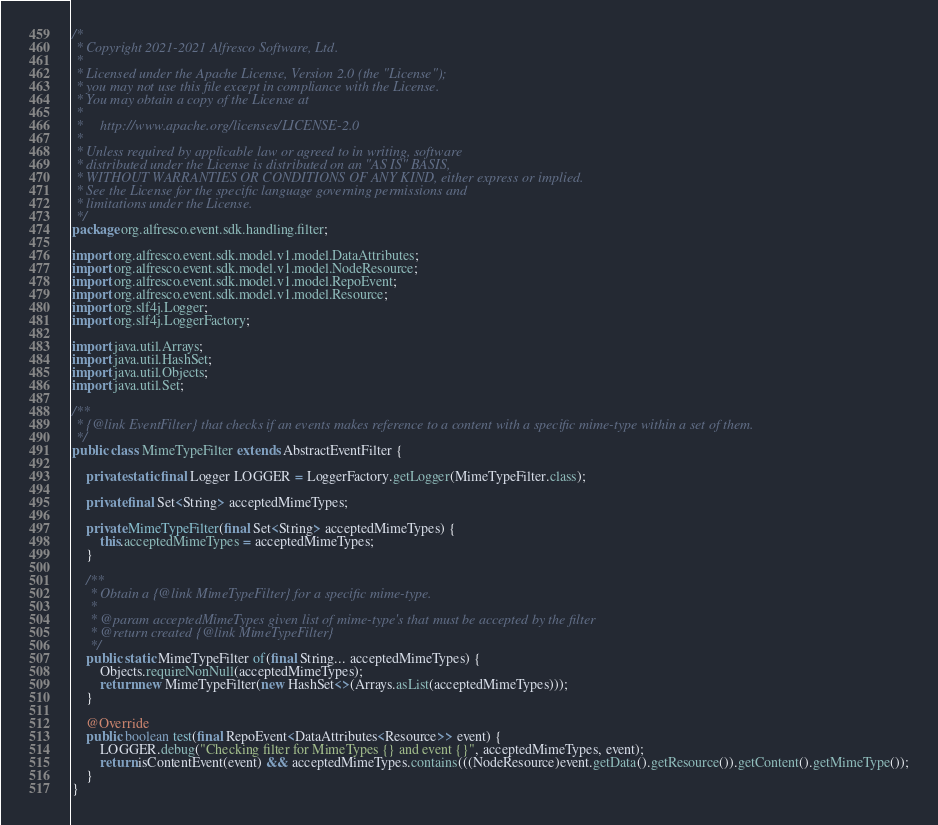<code> <loc_0><loc_0><loc_500><loc_500><_Java_>/*
 * Copyright 2021-2021 Alfresco Software, Ltd.
 *
 * Licensed under the Apache License, Version 2.0 (the "License");
 * you may not use this file except in compliance with the License.
 * You may obtain a copy of the License at
 *
 *     http://www.apache.org/licenses/LICENSE-2.0
 *
 * Unless required by applicable law or agreed to in writing, software
 * distributed under the License is distributed on an "AS IS" BASIS,
 * WITHOUT WARRANTIES OR CONDITIONS OF ANY KIND, either express or implied.
 * See the License for the specific language governing permissions and
 * limitations under the License.
 */
package org.alfresco.event.sdk.handling.filter;

import org.alfresco.event.sdk.model.v1.model.DataAttributes;
import org.alfresco.event.sdk.model.v1.model.NodeResource;
import org.alfresco.event.sdk.model.v1.model.RepoEvent;
import org.alfresco.event.sdk.model.v1.model.Resource;
import org.slf4j.Logger;
import org.slf4j.LoggerFactory;

import java.util.Arrays;
import java.util.HashSet;
import java.util.Objects;
import java.util.Set;

/**
 * {@link EventFilter} that checks if an events makes reference to a content with a specific mime-type within a set of them.
 */
public class MimeTypeFilter extends AbstractEventFilter {

    private static final Logger LOGGER = LoggerFactory.getLogger(MimeTypeFilter.class);

    private final Set<String> acceptedMimeTypes;

    private MimeTypeFilter(final Set<String> acceptedMimeTypes) {
        this.acceptedMimeTypes = acceptedMimeTypes;
    }

    /**
     * Obtain a {@link MimeTypeFilter} for a specific mime-type.
     *
     * @param acceptedMimeTypes given list of mime-type's that must be accepted by the filter
     * @return created {@link MimeTypeFilter}
     */
    public static MimeTypeFilter of(final String... acceptedMimeTypes) {
        Objects.requireNonNull(acceptedMimeTypes);
        return new MimeTypeFilter(new HashSet<>(Arrays.asList(acceptedMimeTypes)));
    }

    @Override
    public boolean test(final RepoEvent<DataAttributes<Resource>> event) {
        LOGGER.debug("Checking filter for MimeTypes {} and event {}", acceptedMimeTypes, event);
        return isContentEvent(event) && acceptedMimeTypes.contains(((NodeResource)event.getData().getResource()).getContent().getMimeType());
    }
}
</code> 